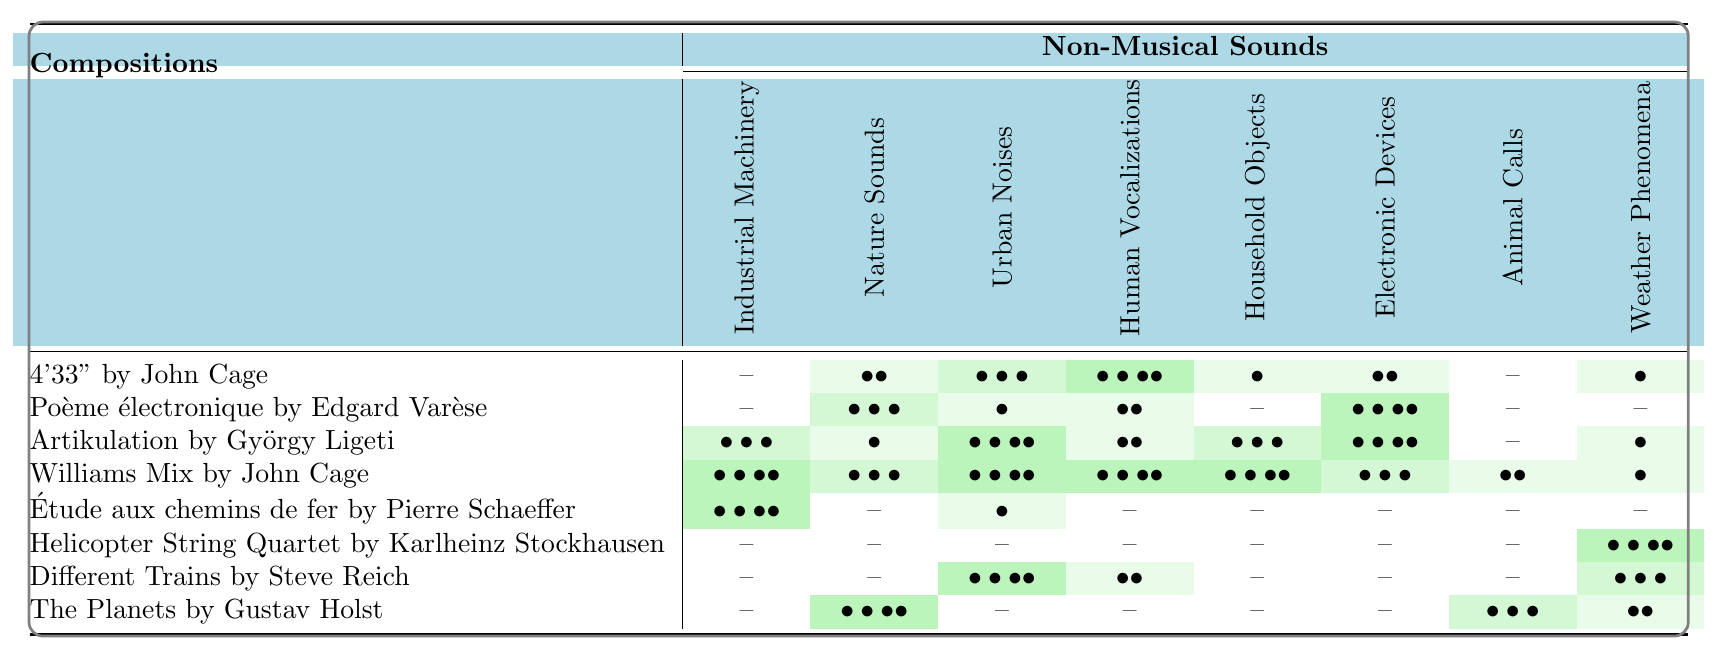What is the highest frequency of non-musical sounds in "Williams Mix" by John Cage? In the table, we look at the row for "Williams Mix." The highest frequency value is found under "Industrial Machinery," which has a value of 4.
Answer: 4 Which composition incorporates the most non-musical sounds overall? We will evaluate all the frequencies in each row of the table. Upon inspecting, "Williams Mix" has 8 indications of non-musical sounds with the highest frequencies, while the other compositions have lower overall totals.
Answer: "Williams Mix" For which non-musical sound does "Helicopter String Quartet" have the highest frequency? Looking at the row for "Helicopter String Quartet," we see that "Weather Phenomena" has the highest frequency of 4.
Answer: Weather Phenomena Does "Étude aux chemins de fer" use "Animal Calls"? Checking the row for "Étude aux chemins de fer," we see that there is no indication of "Animal Calls," as it has a frequency of 0.
Answer: No What is the total frequency of "Nature Sounds" across all compositions? To find this, we would sum the "Nature Sounds" values from each row: 2 (Cage) + 3 (Varèse) + 1 (Ligeti) + 3 (Cage) + 0 (Schaeffer) + 0 (Stockhausen) + 0 (Reich) + 4 (Holst) = 13.
Answer: 13 How many compositions utilize "Electronic Devices" with a frequency of 0? By analyzing the "Electronic Devices" column, we find that "4'33\" by John Cage," "Poème électronique by Edgard Varèse," "Different Trains by Steve Reich," and "The Planets by Gustav Holst" each have a frequency of 0. That's 4 compositions.
Answer: 4 Which composition has the least usage of "Human Vocalizations"? In the "Human Vocalizations" column, we observe the lowest frequency is 0 in "Étude aux chemins de fer," "Helicopter String Quartet," and "The Planets," meaning multiple compositions share the lowest value.
Answer: "Étude aux chemins de fer," "Helicopter String Quartet," and "The Planets" Calculate the average frequency of "Urban Noises" in the compositions. To find the average, we sum the values for "Urban Noises": 3 (Cage) + 1 (Varèse) + 4 (Ligeti) + 4 (Cage) + 1 (Schaeffer) + 0 (Stockhausen) + 4 (Reich) + 0 (Holst) = 18. There are 8 compositions, so the average frequency is 18/8 = 2.25.
Answer: 2.25 How many compositions include "Household Objects" more than once? From the table, "Household Objects" appears more than once in the compositions "4'33\" by John Cage" (1), "Artikulation by György Ligeti" (3), and "Williams Mix by John Cage" (4), thus there are 3 compositions.
Answer: 3 Which non-musical sound is used the least among all compositions? By reviewing each column, it's evident that "Animal Calls" is used the least, as its highest frequency in any composition is 3 in "Different Trains."
Answer: Animal Calls 